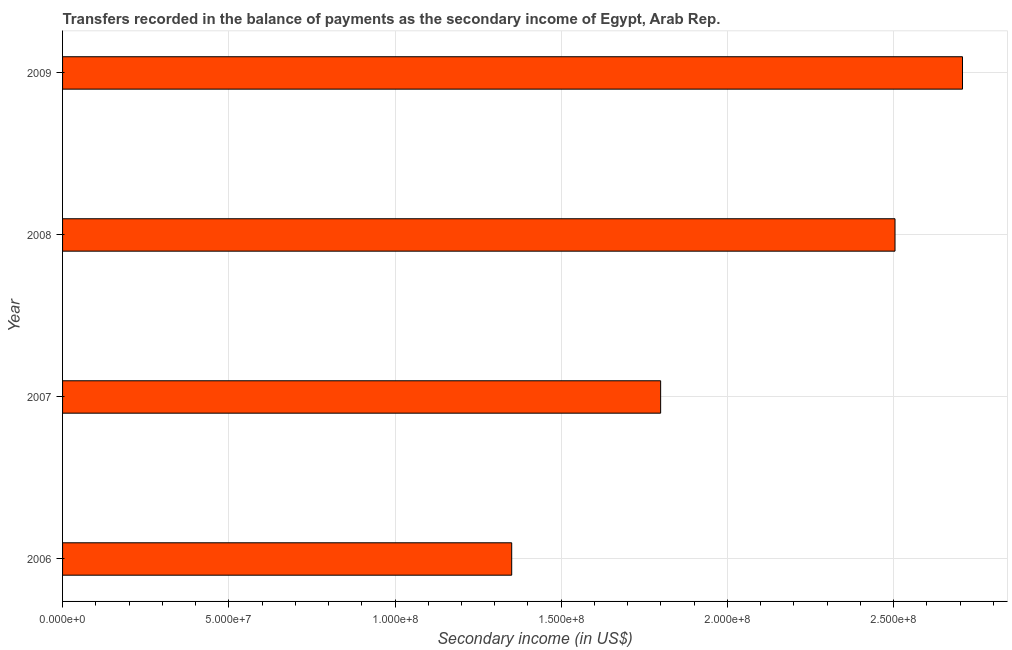Does the graph contain any zero values?
Offer a very short reply. No. Does the graph contain grids?
Offer a terse response. Yes. What is the title of the graph?
Give a very brief answer. Transfers recorded in the balance of payments as the secondary income of Egypt, Arab Rep. What is the label or title of the X-axis?
Your answer should be compact. Secondary income (in US$). What is the label or title of the Y-axis?
Provide a short and direct response. Year. What is the amount of secondary income in 2008?
Your response must be concise. 2.50e+08. Across all years, what is the maximum amount of secondary income?
Give a very brief answer. 2.71e+08. Across all years, what is the minimum amount of secondary income?
Your answer should be very brief. 1.35e+08. What is the sum of the amount of secondary income?
Offer a very short reply. 8.36e+08. What is the difference between the amount of secondary income in 2007 and 2008?
Provide a succinct answer. -7.05e+07. What is the average amount of secondary income per year?
Offer a very short reply. 2.09e+08. What is the median amount of secondary income?
Ensure brevity in your answer.  2.15e+08. In how many years, is the amount of secondary income greater than 70000000 US$?
Keep it short and to the point. 4. Do a majority of the years between 2009 and 2007 (inclusive) have amount of secondary income greater than 260000000 US$?
Your response must be concise. Yes. What is the ratio of the amount of secondary income in 2006 to that in 2009?
Provide a succinct answer. 0.5. Is the amount of secondary income in 2006 less than that in 2009?
Provide a short and direct response. Yes. Is the difference between the amount of secondary income in 2006 and 2007 greater than the difference between any two years?
Make the answer very short. No. What is the difference between the highest and the second highest amount of secondary income?
Offer a very short reply. 2.03e+07. Is the sum of the amount of secondary income in 2006 and 2007 greater than the maximum amount of secondary income across all years?
Ensure brevity in your answer.  Yes. What is the difference between the highest and the lowest amount of secondary income?
Your response must be concise. 1.36e+08. How many bars are there?
Your response must be concise. 4. What is the difference between two consecutive major ticks on the X-axis?
Provide a succinct answer. 5.00e+07. What is the Secondary income (in US$) in 2006?
Your answer should be very brief. 1.35e+08. What is the Secondary income (in US$) in 2007?
Provide a short and direct response. 1.80e+08. What is the Secondary income (in US$) of 2008?
Provide a succinct answer. 2.50e+08. What is the Secondary income (in US$) of 2009?
Give a very brief answer. 2.71e+08. What is the difference between the Secondary income (in US$) in 2006 and 2007?
Make the answer very short. -4.48e+07. What is the difference between the Secondary income (in US$) in 2006 and 2008?
Provide a succinct answer. -1.15e+08. What is the difference between the Secondary income (in US$) in 2006 and 2009?
Give a very brief answer. -1.36e+08. What is the difference between the Secondary income (in US$) in 2007 and 2008?
Provide a succinct answer. -7.05e+07. What is the difference between the Secondary income (in US$) in 2007 and 2009?
Provide a short and direct response. -9.08e+07. What is the difference between the Secondary income (in US$) in 2008 and 2009?
Your answer should be very brief. -2.03e+07. What is the ratio of the Secondary income (in US$) in 2006 to that in 2007?
Ensure brevity in your answer.  0.75. What is the ratio of the Secondary income (in US$) in 2006 to that in 2008?
Provide a succinct answer. 0.54. What is the ratio of the Secondary income (in US$) in 2006 to that in 2009?
Provide a succinct answer. 0.5. What is the ratio of the Secondary income (in US$) in 2007 to that in 2008?
Provide a succinct answer. 0.72. What is the ratio of the Secondary income (in US$) in 2007 to that in 2009?
Offer a very short reply. 0.67. What is the ratio of the Secondary income (in US$) in 2008 to that in 2009?
Offer a very short reply. 0.93. 